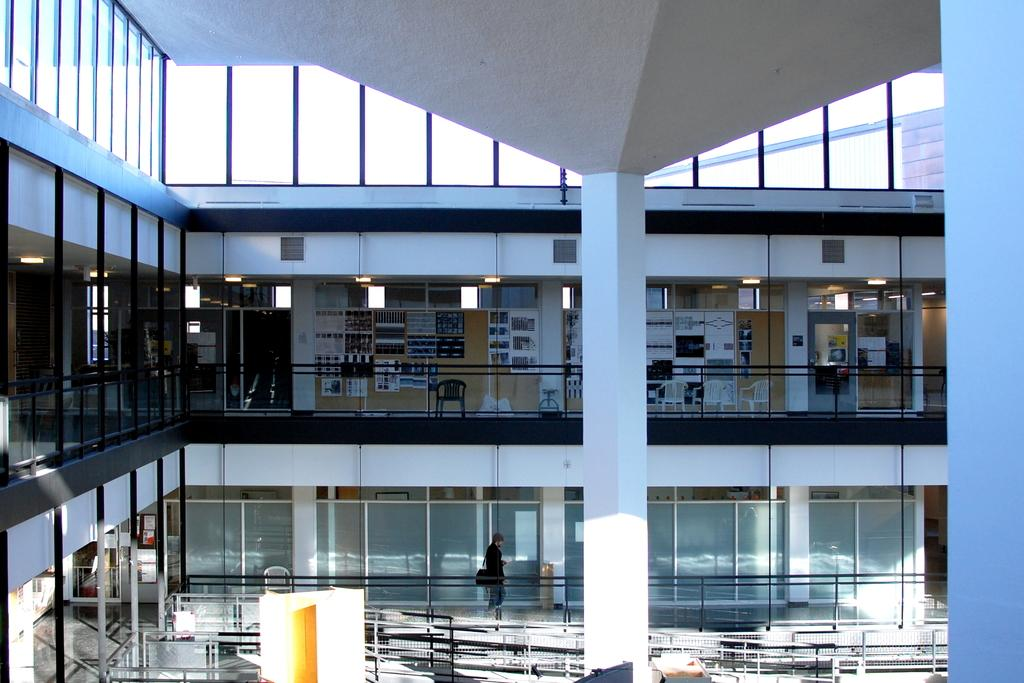What is the person in the image doing? The person is standing on the floor in the image. What architectural feature can be seen in the image? There is a pillar in the image. What type of barrier is present in the image? There is a fence in the image. What type of seating is visible in the image? There is a chair on the floor in the image. What type of wall is present in the image? There is a framed glass wall in the image. What type of access point is present in the image? There are doors in the image. What type of objects are on the floor in the image? There are objects on the floor in the image. How many eggs are visible in the image? There are no eggs visible in the image. What type of joke is being told in the image? There is no joke being told in the image. 